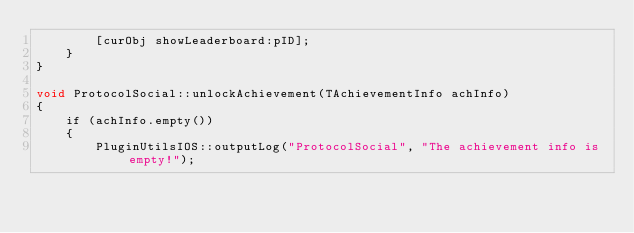Convert code to text. <code><loc_0><loc_0><loc_500><loc_500><_ObjectiveC_>        [curObj showLeaderboard:pID];
    }
}

void ProtocolSocial::unlockAchievement(TAchievementInfo achInfo)
{
    if (achInfo.empty())
    {
        PluginUtilsIOS::outputLog("ProtocolSocial", "The achievement info is empty!");</code> 